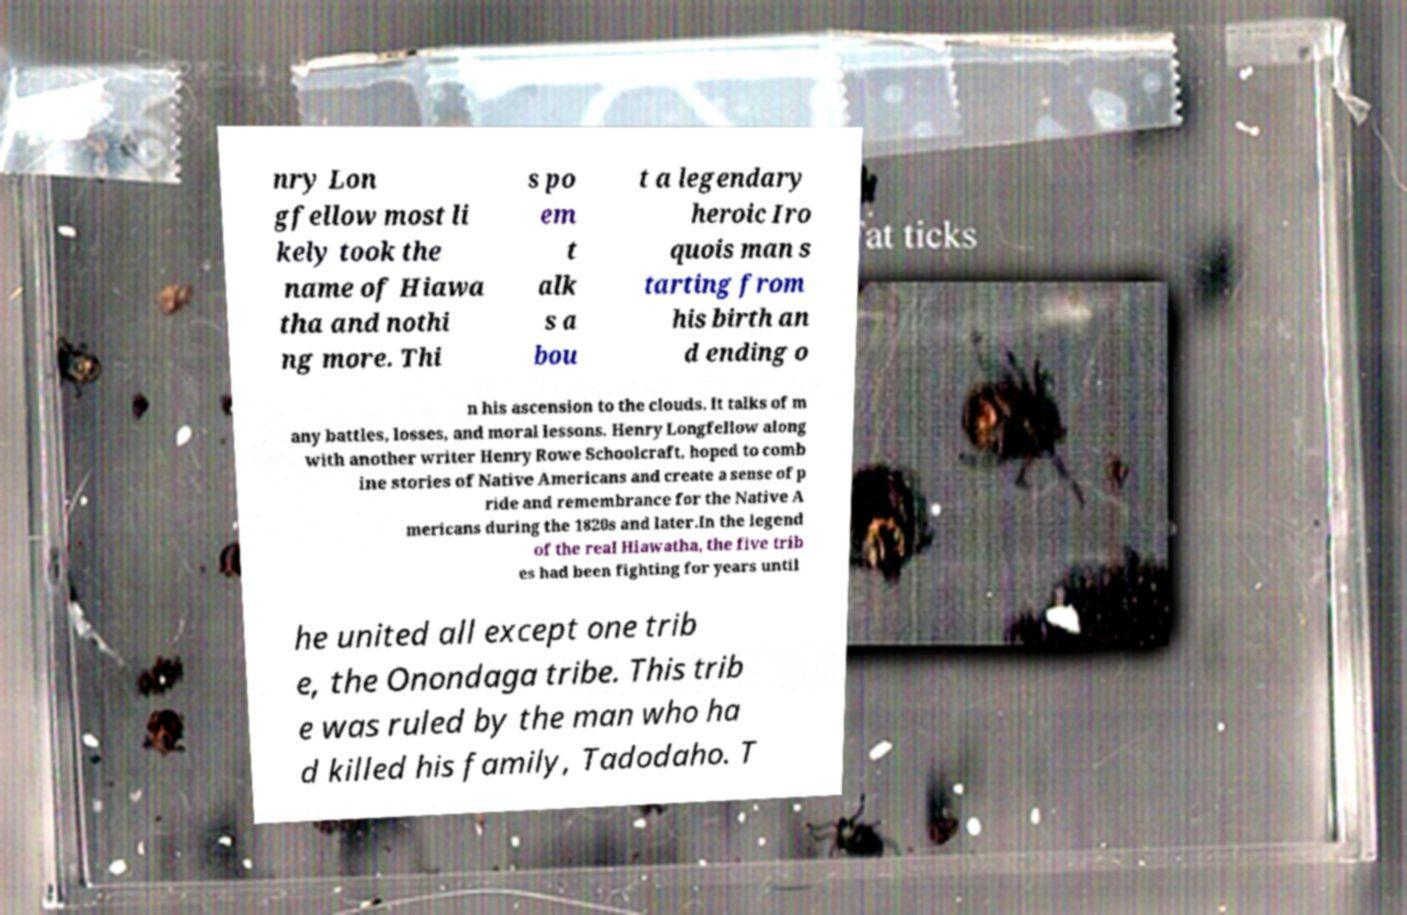What messages or text are displayed in this image? I need them in a readable, typed format. nry Lon gfellow most li kely took the name of Hiawa tha and nothi ng more. Thi s po em t alk s a bou t a legendary heroic Iro quois man s tarting from his birth an d ending o n his ascension to the clouds. It talks of m any battles, losses, and moral lessons. Henry Longfellow along with another writer Henry Rowe Schoolcraft, hoped to comb ine stories of Native Americans and create a sense of p ride and remembrance for the Native A mericans during the 1820s and later.In the legend of the real Hiawatha, the five trib es had been fighting for years until he united all except one trib e, the Onondaga tribe. This trib e was ruled by the man who ha d killed his family, Tadodaho. T 